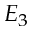<formula> <loc_0><loc_0><loc_500><loc_500>E _ { 3 }</formula> 